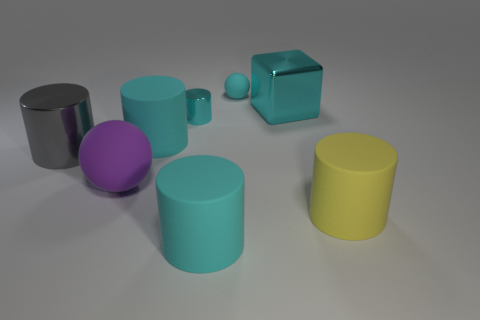How many other objects are there of the same color as the tiny cylinder?
Keep it short and to the point. 4. The cylinder that is both to the right of the big gray shiny object and on the left side of the small cyan metal cylinder is what color?
Your response must be concise. Cyan. There is a metallic cylinder that is the same color as the small matte thing; what size is it?
Your answer should be compact. Small. There is a large metallic thing behind the tiny cyan metal cylinder; is it the same shape as the big matte thing that is in front of the yellow matte thing?
Provide a short and direct response. No. There is a cyan rubber sphere; how many large cyan things are to the left of it?
Keep it short and to the point. 2. Does the big cyan block that is to the left of the big yellow cylinder have the same material as the purple sphere?
Your response must be concise. No. The big object that is the same shape as the small cyan rubber object is what color?
Your answer should be very brief. Purple. What is the shape of the tiny cyan matte object?
Provide a short and direct response. Sphere. What number of things are either yellow metal objects or metallic cylinders?
Offer a terse response. 2. There is a rubber sphere behind the block; is its color the same as the big object on the right side of the cyan metallic block?
Your response must be concise. No. 